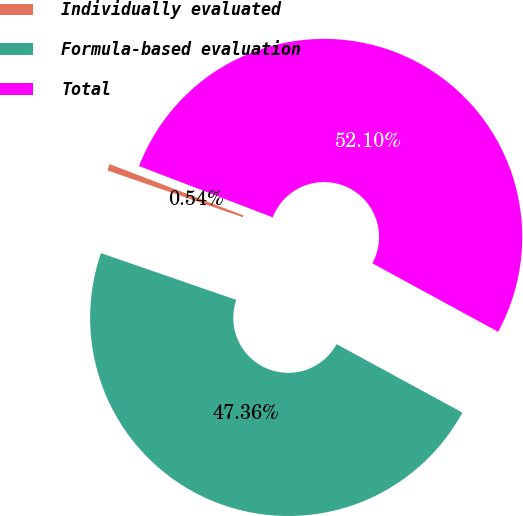<chart> <loc_0><loc_0><loc_500><loc_500><pie_chart><fcel>Individually evaluated<fcel>Formula-based evaluation<fcel>Total<nl><fcel>0.54%<fcel>47.36%<fcel>52.1%<nl></chart> 